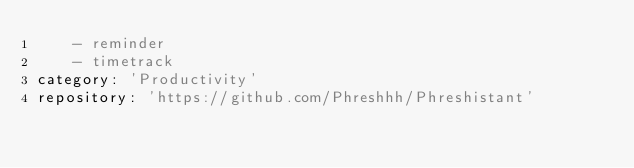<code> <loc_0><loc_0><loc_500><loc_500><_YAML_>    - reminder
    - timetrack
category: 'Productivity'
repository: 'https://github.com/Phreshhh/Phreshistant'</code> 